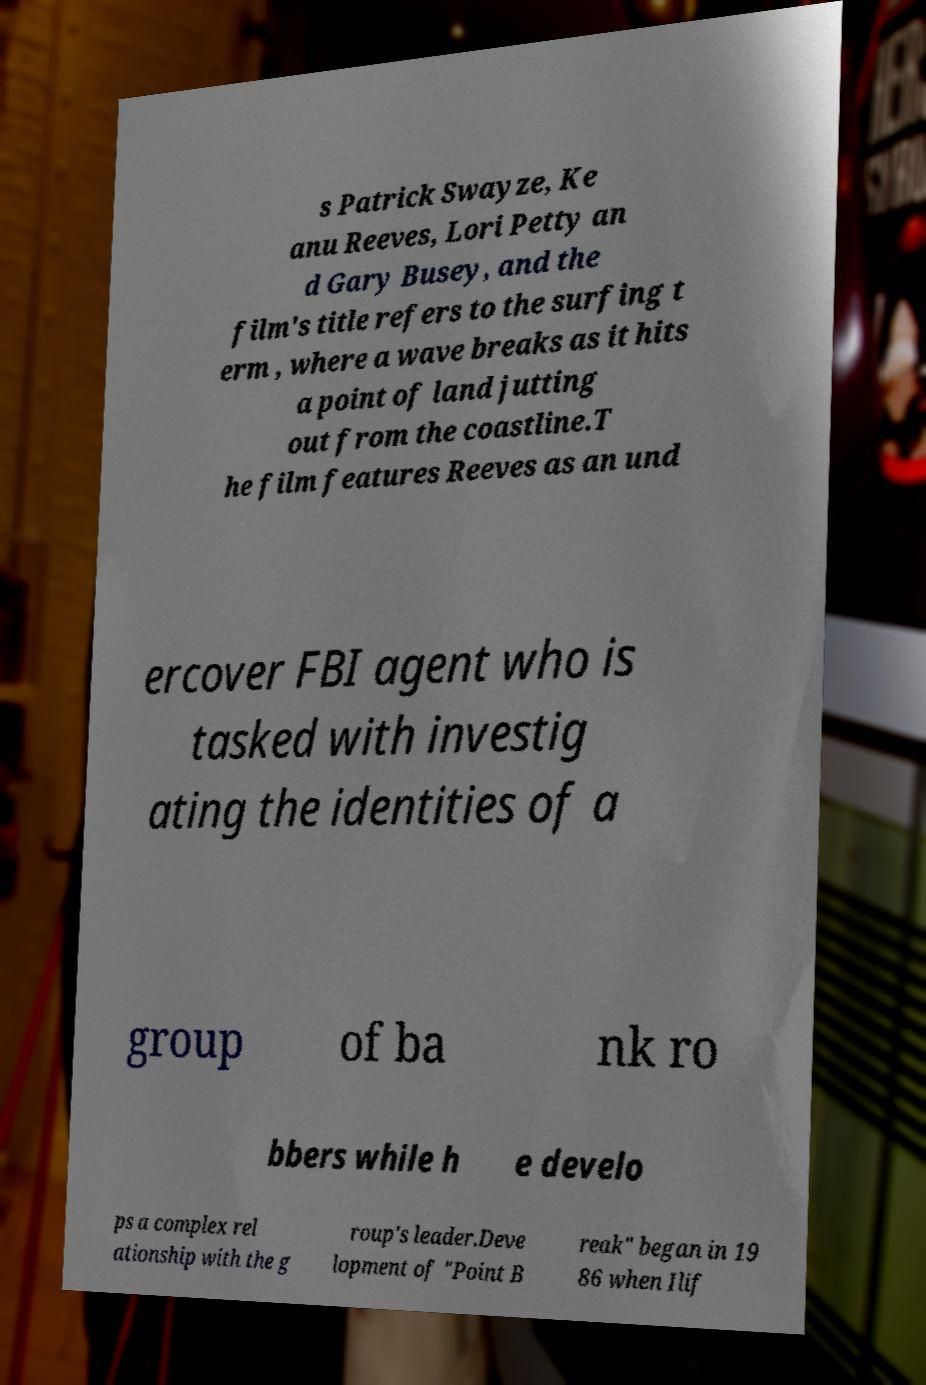Could you extract and type out the text from this image? s Patrick Swayze, Ke anu Reeves, Lori Petty an d Gary Busey, and the film's title refers to the surfing t erm , where a wave breaks as it hits a point of land jutting out from the coastline.T he film features Reeves as an und ercover FBI agent who is tasked with investig ating the identities of a group of ba nk ro bbers while h e develo ps a complex rel ationship with the g roup's leader.Deve lopment of "Point B reak" began in 19 86 when Ilif 